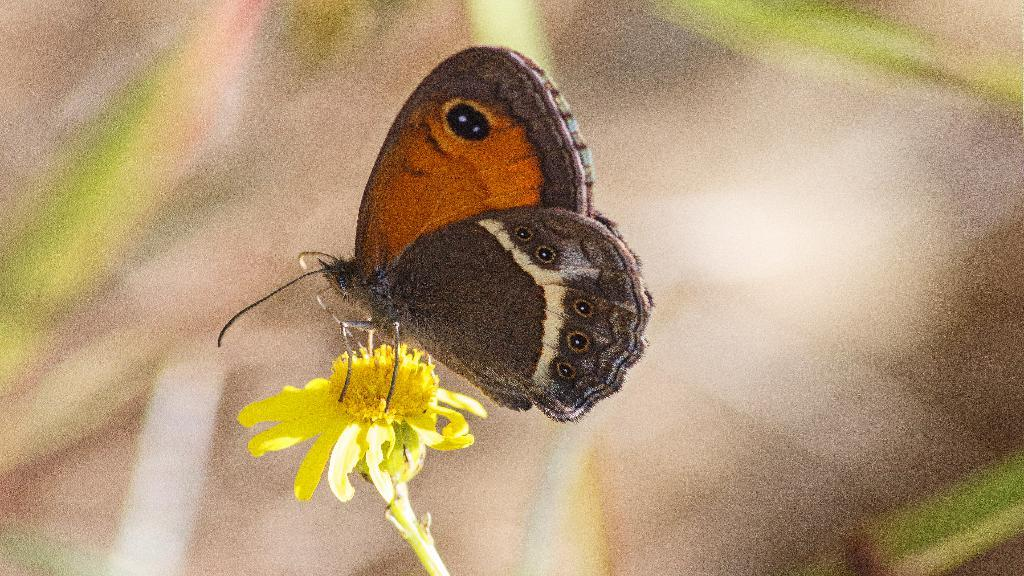What is the main subject of the image? The main subject of the image is a butterfly. Where is the butterfly located in the image? The butterfly is on a flower in the image. What is the position of the butterfly and flower in the image? The butterfly and flower are in the center of the image. What type of bait is being used to attract the butterfly in the image? There is no bait present in the image, as the butterfly is naturally on the flower. What property is being sold in the image? There is no property being sold in the image; it features a butterfly on a flower. 